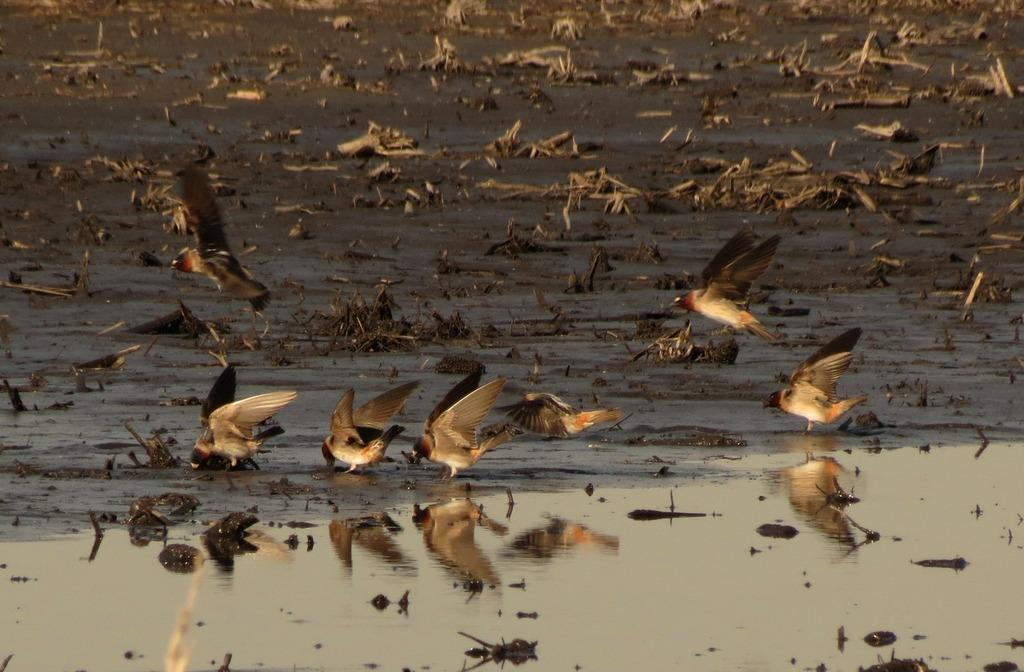What is the primary element in the image? There is water in the image. What can be seen in the foreground of the image? There are birds in the front of the image. What is visible in the background of the image? There are objects on the ground in the background of the image. What is reflected on the water in the image? There is a reflection of birds on the water in the image. How many chairs can be seen in the image? There are no chairs present in the image. What type of chickens are swimming in the water? There are no chickens present in the image; it features birds, not chickens. 